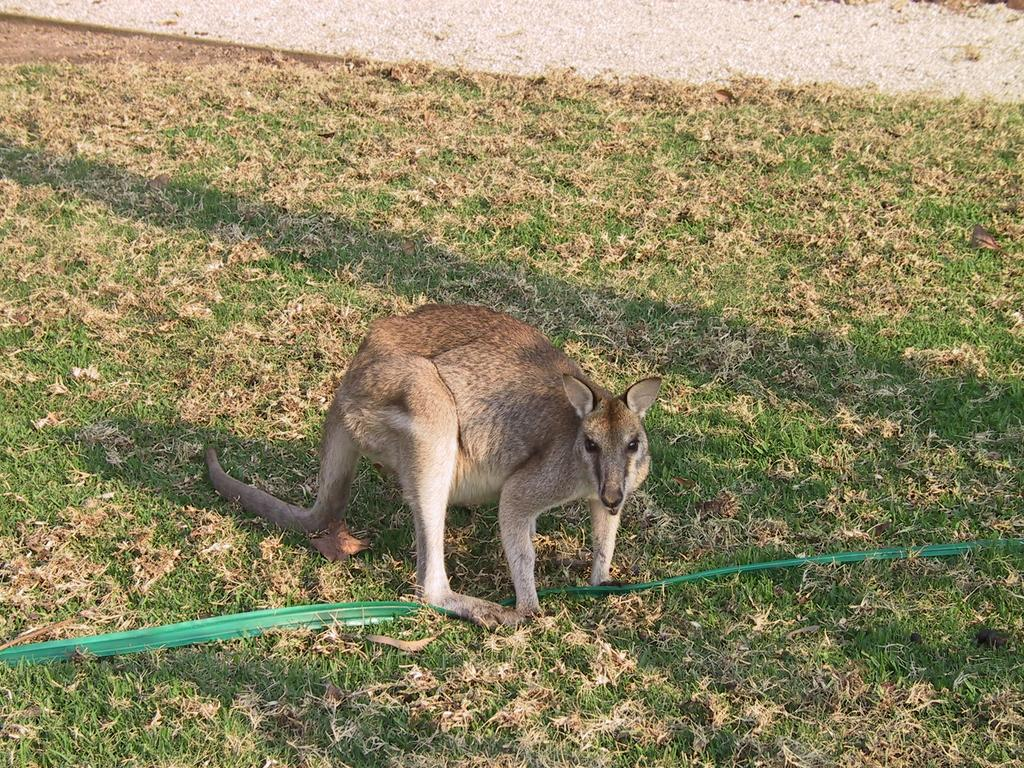What type of animal is on the ground in the image? The specific type of animal cannot be determined from the image, but it is an animal on the ground. What is the ground covered with? The ground has grass. What color is the object on the ground? The object on the ground is green. What can be seen in the distance in the image? There is a road visible in the background of the image. What type of cork can be seen in the image? There is no cork present in the image. How many pears are visible in the image? There are no pears visible in the image. 